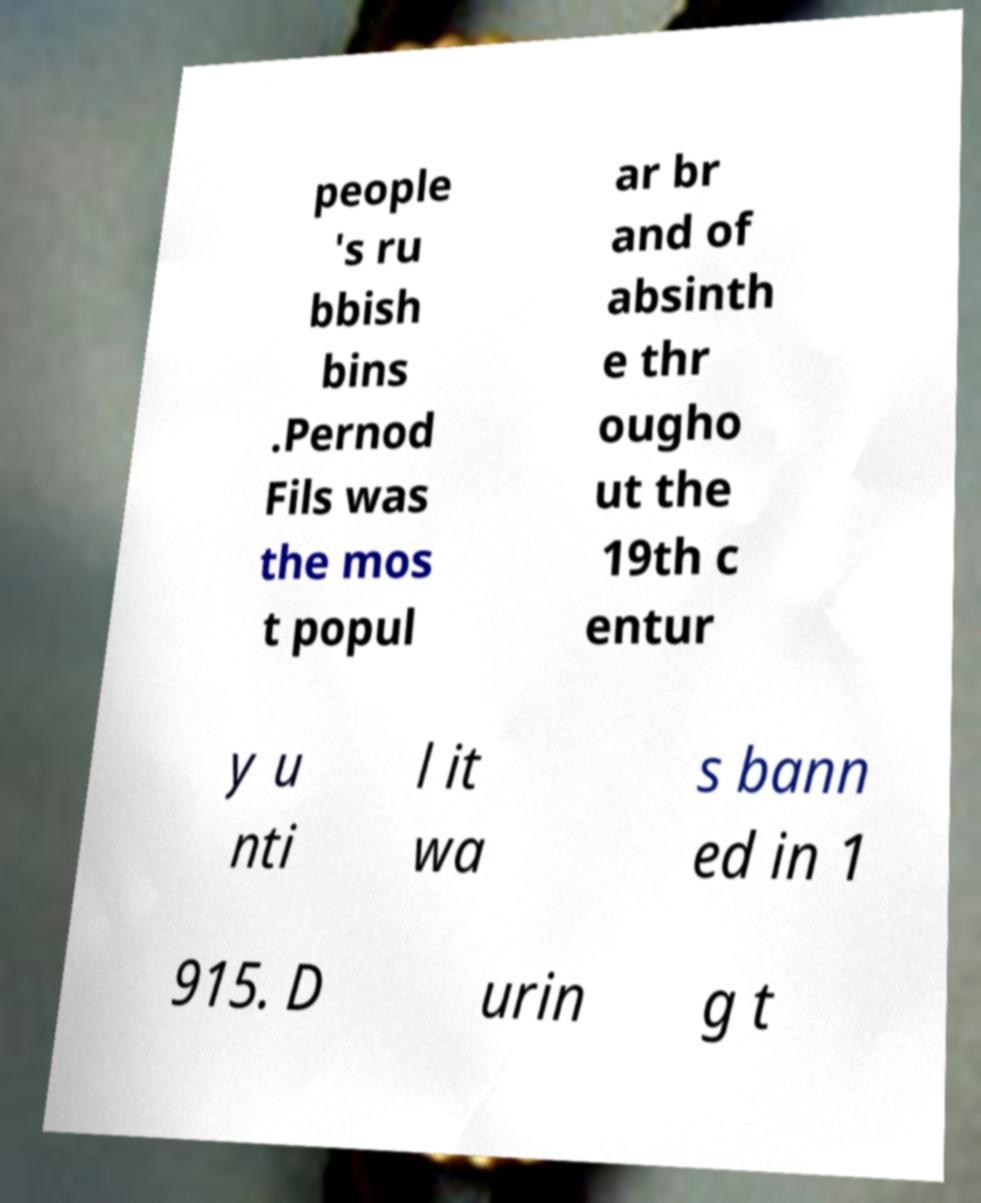For documentation purposes, I need the text within this image transcribed. Could you provide that? people 's ru bbish bins .Pernod Fils was the mos t popul ar br and of absinth e thr ougho ut the 19th c entur y u nti l it wa s bann ed in 1 915. D urin g t 